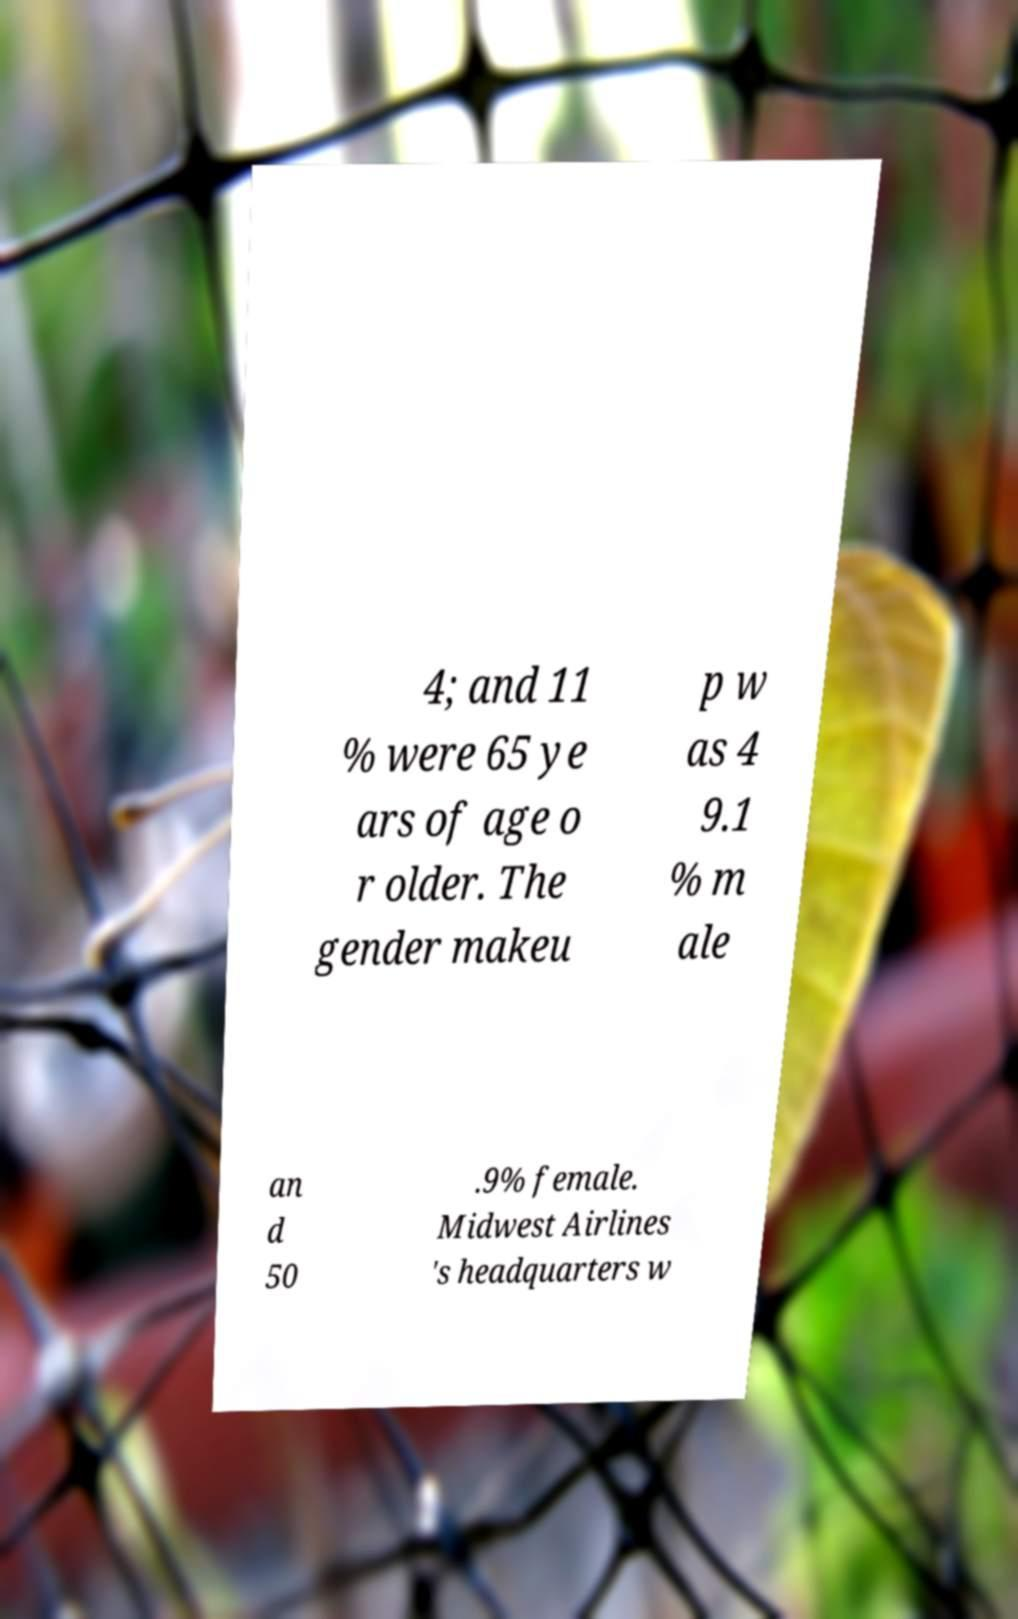Please read and relay the text visible in this image. What does it say? 4; and 11 % were 65 ye ars of age o r older. The gender makeu p w as 4 9.1 % m ale an d 50 .9% female. Midwest Airlines 's headquarters w 